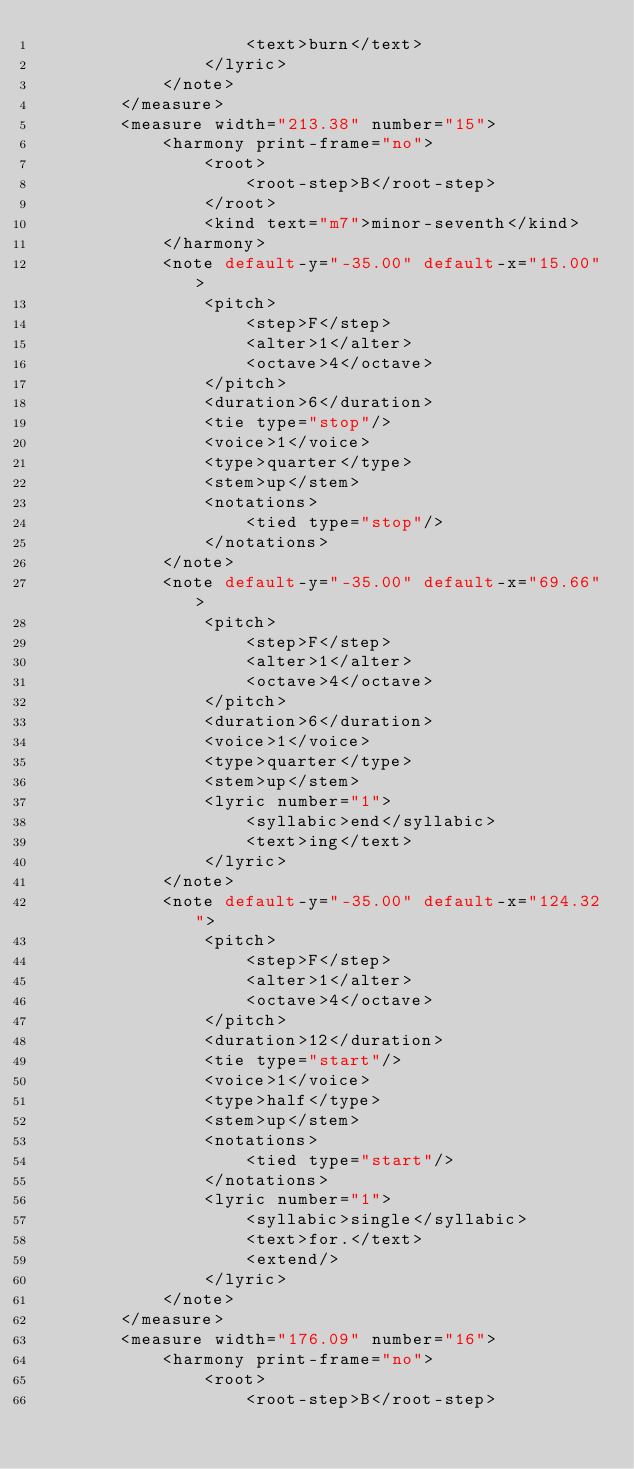Convert code to text. <code><loc_0><loc_0><loc_500><loc_500><_XML_>                    <text>burn</text>
                </lyric>
            </note>
        </measure>
        <measure width="213.38" number="15">
            <harmony print-frame="no">
                <root>
                    <root-step>B</root-step>
                </root>
                <kind text="m7">minor-seventh</kind>
            </harmony>
            <note default-y="-35.00" default-x="15.00">
                <pitch>
                    <step>F</step>
                    <alter>1</alter>
                    <octave>4</octave>
                </pitch>
                <duration>6</duration>
                <tie type="stop"/>
                <voice>1</voice>
                <type>quarter</type>
                <stem>up</stem>
                <notations>
                    <tied type="stop"/>
                </notations>
            </note>
            <note default-y="-35.00" default-x="69.66">
                <pitch>
                    <step>F</step>
                    <alter>1</alter>
                    <octave>4</octave>
                </pitch>
                <duration>6</duration>
                <voice>1</voice>
                <type>quarter</type>
                <stem>up</stem>
                <lyric number="1">
                    <syllabic>end</syllabic>
                    <text>ing</text>
                </lyric>
            </note>
            <note default-y="-35.00" default-x="124.32">
                <pitch>
                    <step>F</step>
                    <alter>1</alter>
                    <octave>4</octave>
                </pitch>
                <duration>12</duration>
                <tie type="start"/>
                <voice>1</voice>
                <type>half</type>
                <stem>up</stem>
                <notations>
                    <tied type="start"/>
                </notations>
                <lyric number="1">
                    <syllabic>single</syllabic>
                    <text>for.</text>
                    <extend/>
                </lyric>
            </note>
        </measure>
        <measure width="176.09" number="16">
            <harmony print-frame="no">
                <root>
                    <root-step>B</root-step></code> 